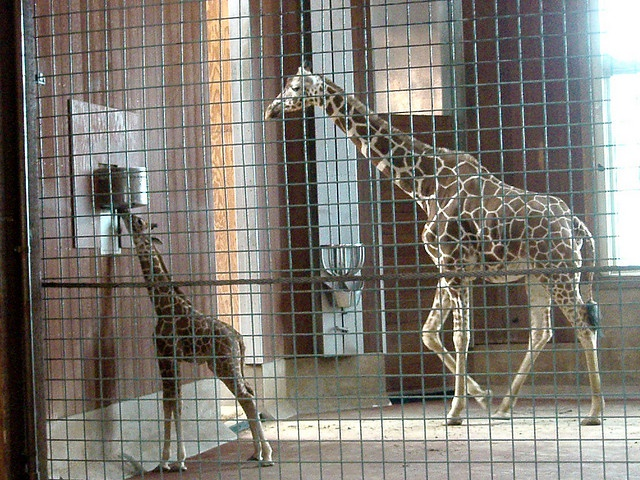Describe the objects in this image and their specific colors. I can see giraffe in black, gray, and darkgray tones and giraffe in black, gray, and darkgreen tones in this image. 